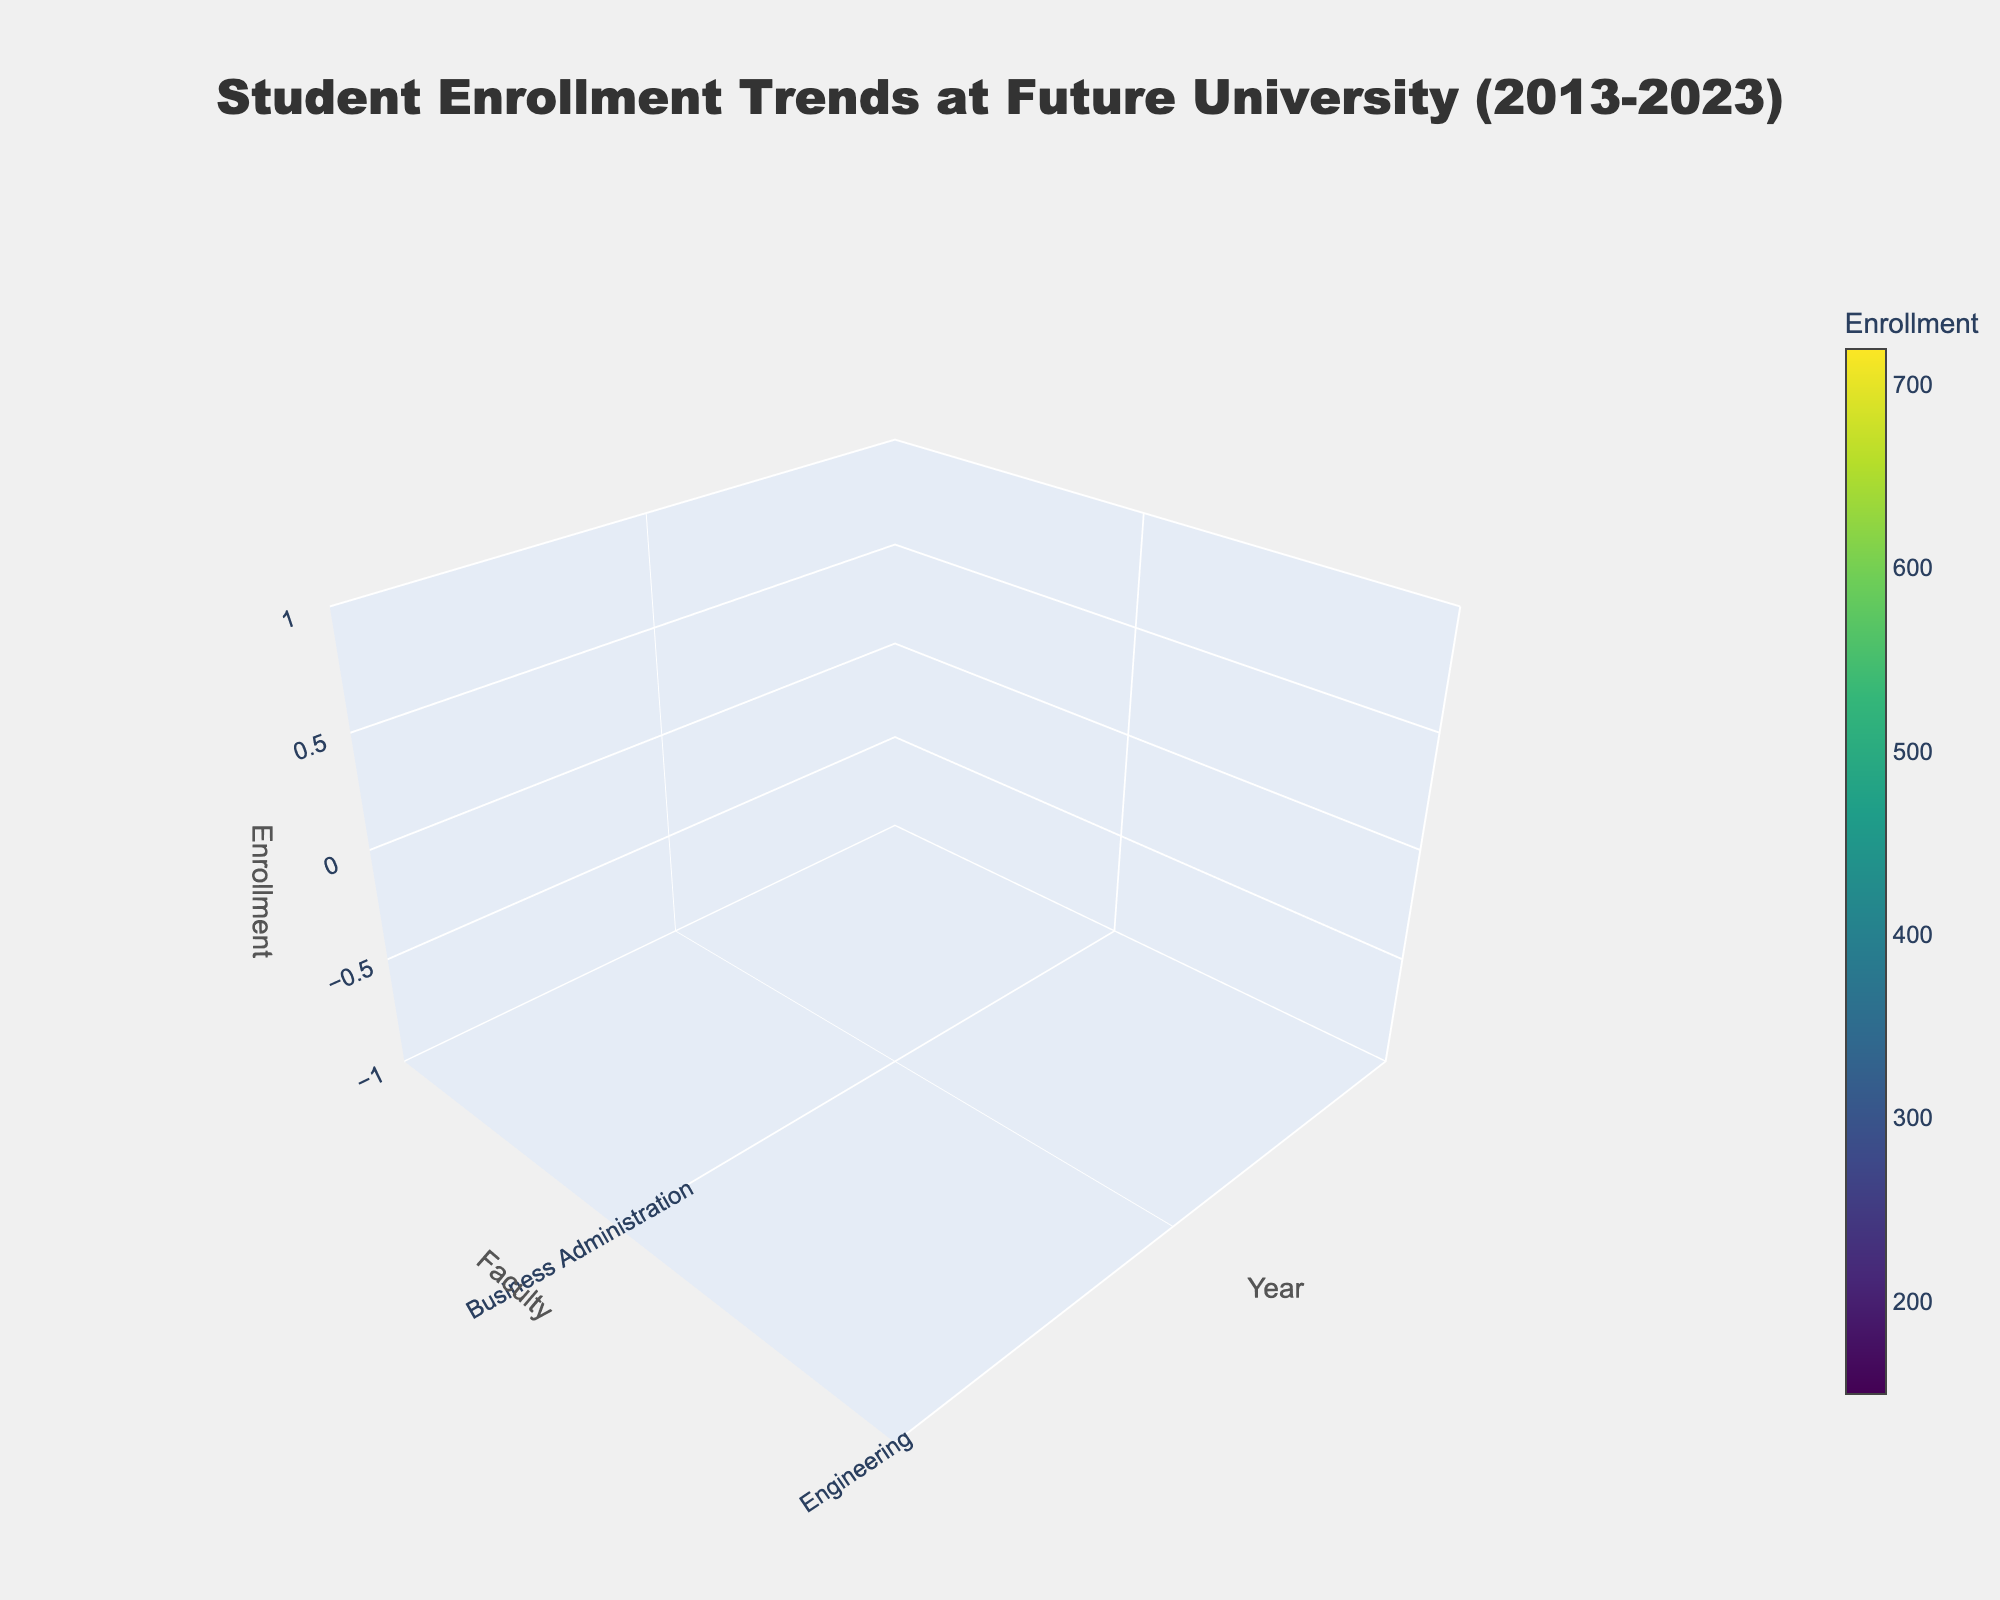What are the faculties featured in the plot? The faculties can be seen on the y-axis, corresponding to different labels. These faculties are listed based on the provided data.
Answer: Business Administration, Engineering, Computer Science, Pharmacy, Dentistry What is the title of the plot? The title is displayed prominently at the top of the figure.
Answer: Student Enrollment Trends at Future University (2013-2023) Which faculty had the highest enrollment in 2023? By observing the highest z-axis value (enrollment) for the 2023 data point on the x-axis, we can find the faculty with the highest enrollment.
Answer: Business Administration Estimate the total enrollment across all faculties in 2019. Sum the enrollment values for all faculties in 2019 from the plot.
Answer: 2000 Which faculty showed a steady increase in enrollment from 2013 to 2023? Examine the trend lines or surfaces representing each faculty over the years, focusing on the overall upward trajectory.
Answer: Engineering How does the enrollment in Computer Science in 2015 compare to that in 2023? Compare the z-axis values for Computer Science for the years 2015 and 2023.
Answer: 240 more in 2023 When did the Faculty of Pharmacy experience the highest enrollment? Identify the peak value on the z-axis for the surface representing Pharmacy over the years.
Answer: 2023 What is the average enrollment for the Faculty of Dentistry over the decade? Sum the enrollment values for Dentistry from 2013 to 2023 and divide by the number of years.
Answer: (150 + 180 + 210 + 240 + 270 + 300)/6 = 225 Which year saw the largest increase in total enrollment across all faculties compared to the previous year? Calculate the increase in total enrollment from year to year and identify the largest difference.
Answer: 2015 (820 increase) How does the enrollment trend for Business Administration compare with that of Pharmacy? Compare the upward or downward trends in the surfaces representing Business Administration and Pharmacy over the years.
Answer: Both increasing, Business Administration rises faster 